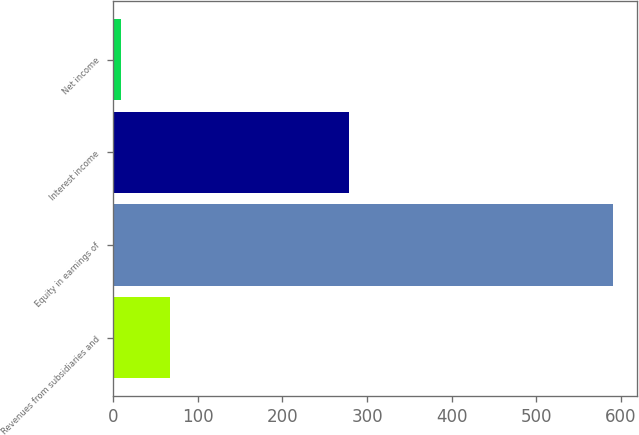Convert chart. <chart><loc_0><loc_0><loc_500><loc_500><bar_chart><fcel>Revenues from subsidiaries and<fcel>Equity in earnings of<fcel>Interest income<fcel>Net income<nl><fcel>67.1<fcel>590<fcel>279<fcel>9<nl></chart> 